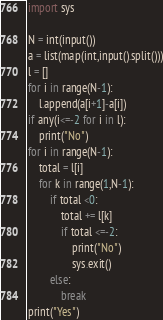<code> <loc_0><loc_0><loc_500><loc_500><_Python_>import sys

N = int(input())
a = list(map(int,input().split()))
l = []
for i in range(N-1):
    l.append(a[i+1]-a[i])
if any(i<=-2 for i in l):
    print("No")
for i in range(N-1):
    total = l[i]
    for k in range(1,N-1):
        if total <0:
            total += l[k]
            if total <=-2:
                print("No")
                sys.exit()
        else:
            break
print("Yes")
</code> 